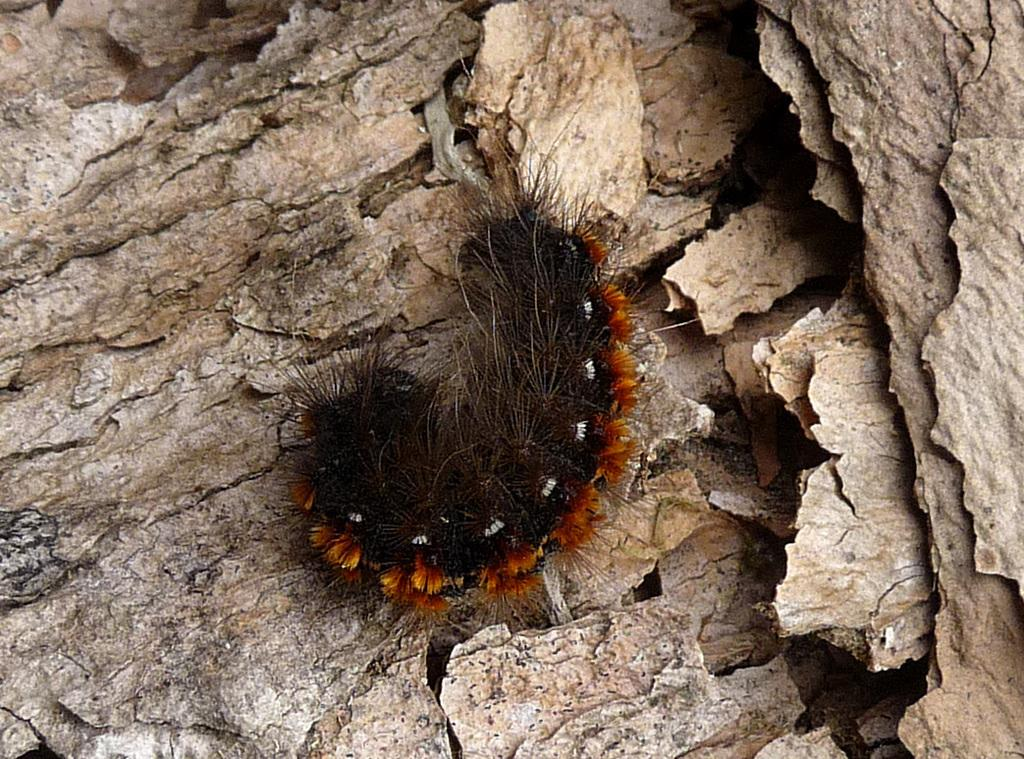What is the main subject of the image? The main subject of the image is a caterpillar. Where is the caterpillar located in the image? The caterpillar is on a wooden surface. What rhythm does the caterpillar follow while moving on the wooden surface? The image does not show the caterpillar moving, and therefore, it is not possible to determine any rhythm it might follow. 